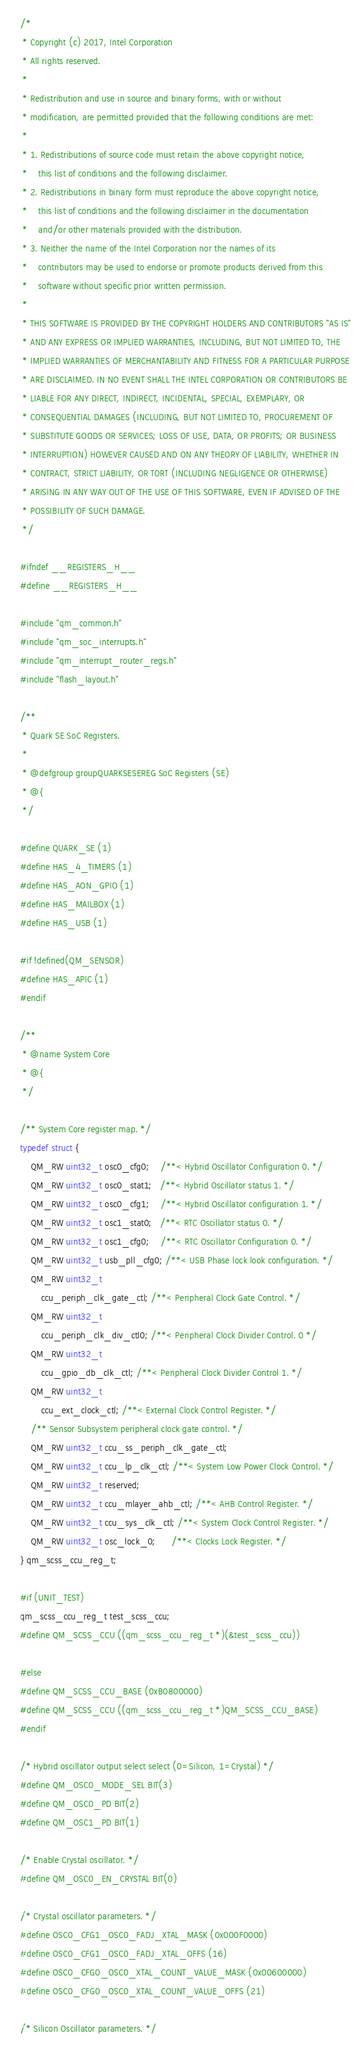<code> <loc_0><loc_0><loc_500><loc_500><_C_>/*
 * Copyright (c) 2017, Intel Corporation
 * All rights reserved.
 *
 * Redistribution and use in source and binary forms, with or without
 * modification, are permitted provided that the following conditions are met:
 *
 * 1. Redistributions of source code must retain the above copyright notice,
 *    this list of conditions and the following disclaimer.
 * 2. Redistributions in binary form must reproduce the above copyright notice,
 *    this list of conditions and the following disclaimer in the documentation
 *    and/or other materials provided with the distribution.
 * 3. Neither the name of the Intel Corporation nor the names of its
 *    contributors may be used to endorse or promote products derived from this
 *    software without specific prior written permission.
 *
 * THIS SOFTWARE IS PROVIDED BY THE COPYRIGHT HOLDERS AND CONTRIBUTORS "AS IS"
 * AND ANY EXPRESS OR IMPLIED WARRANTIES, INCLUDING, BUT NOT LIMITED TO, THE
 * IMPLIED WARRANTIES OF MERCHANTABILITY AND FITNESS FOR A PARTICULAR PURPOSE
 * ARE DISCLAIMED. IN NO EVENT SHALL THE INTEL CORPORATION OR CONTRIBUTORS BE
 * LIABLE FOR ANY DIRECT, INDIRECT, INCIDENTAL, SPECIAL, EXEMPLARY, OR
 * CONSEQUENTIAL DAMAGES (INCLUDING, BUT NOT LIMITED TO, PROCUREMENT OF
 * SUBSTITUTE GOODS OR SERVICES; LOSS OF USE, DATA, OR PROFITS; OR BUSINESS
 * INTERRUPTION) HOWEVER CAUSED AND ON ANY THEORY OF LIABILITY, WHETHER IN
 * CONTRACT, STRICT LIABILITY, OR TORT (INCLUDING NEGLIGENCE OR OTHERWISE)
 * ARISING IN ANY WAY OUT OF THE USE OF THIS SOFTWARE, EVEN IF ADVISED OF THE
 * POSSIBILITY OF SUCH DAMAGE.
 */

#ifndef __REGISTERS_H__
#define __REGISTERS_H__

#include "qm_common.h"
#include "qm_soc_interrupts.h"
#include "qm_interrupt_router_regs.h"
#include "flash_layout.h"

/**
 * Quark SE SoC Registers.
 *
 * @defgroup groupQUARKSESEREG SoC Registers (SE)
 * @{
 */

#define QUARK_SE (1)
#define HAS_4_TIMERS (1)
#define HAS_AON_GPIO (1)
#define HAS_MAILBOX (1)
#define HAS_USB (1)

#if !defined(QM_SENSOR)
#define HAS_APIC (1)
#endif

/**
 * @name System Core
 * @{
 */

/** System Core register map. */
typedef struct {
	QM_RW uint32_t osc0_cfg0;    /**< Hybrid Oscillator Configuration 0. */
	QM_RW uint32_t osc0_stat1;   /**< Hybrid Oscillator status 1. */
	QM_RW uint32_t osc0_cfg1;    /**< Hybrid Oscillator configuration 1. */
	QM_RW uint32_t osc1_stat0;   /**< RTC Oscillator status 0. */
	QM_RW uint32_t osc1_cfg0;    /**< RTC Oscillator Configuration 0. */
	QM_RW uint32_t usb_pll_cfg0; /**< USB Phase lock look configuration. */
	QM_RW uint32_t
	    ccu_periph_clk_gate_ctl; /**< Peripheral Clock Gate Control. */
	QM_RW uint32_t
	    ccu_periph_clk_div_ctl0; /**< Peripheral Clock Divider Control. 0 */
	QM_RW uint32_t
	    ccu_gpio_db_clk_ctl; /**< Peripheral Clock Divider Control 1. */
	QM_RW uint32_t
	    ccu_ext_clock_ctl; /**< External Clock Control Register. */
	/** Sensor Subsystem peripheral clock gate control. */
	QM_RW uint32_t ccu_ss_periph_clk_gate_ctl;
	QM_RW uint32_t ccu_lp_clk_ctl; /**< System Low Power Clock Control. */
	QM_RW uint32_t reserved;
	QM_RW uint32_t ccu_mlayer_ahb_ctl; /**< AHB Control Register. */
	QM_RW uint32_t ccu_sys_clk_ctl; /**< System Clock Control Register. */
	QM_RW uint32_t osc_lock_0;      /**< Clocks Lock Register. */
} qm_scss_ccu_reg_t;

#if (UNIT_TEST)
qm_scss_ccu_reg_t test_scss_ccu;
#define QM_SCSS_CCU ((qm_scss_ccu_reg_t *)(&test_scss_ccu))

#else
#define QM_SCSS_CCU_BASE (0xB0800000)
#define QM_SCSS_CCU ((qm_scss_ccu_reg_t *)QM_SCSS_CCU_BASE)
#endif

/* Hybrid oscillator output select select (0=Silicon, 1=Crystal) */
#define QM_OSC0_MODE_SEL BIT(3)
#define QM_OSC0_PD BIT(2)
#define QM_OSC1_PD BIT(1)

/* Enable Crystal oscillator. */
#define QM_OSC0_EN_CRYSTAL BIT(0)

/* Crystal oscillator parameters. */
#define OSC0_CFG1_OSC0_FADJ_XTAL_MASK (0x000F0000)
#define OSC0_CFG1_OSC0_FADJ_XTAL_OFFS (16)
#define OSC0_CFG0_OSC0_XTAL_COUNT_VALUE_MASK (0x00600000)
#define OSC0_CFG0_OSC0_XTAL_COUNT_VALUE_OFFS (21)

/* Silicon Oscillator parameters. */</code> 